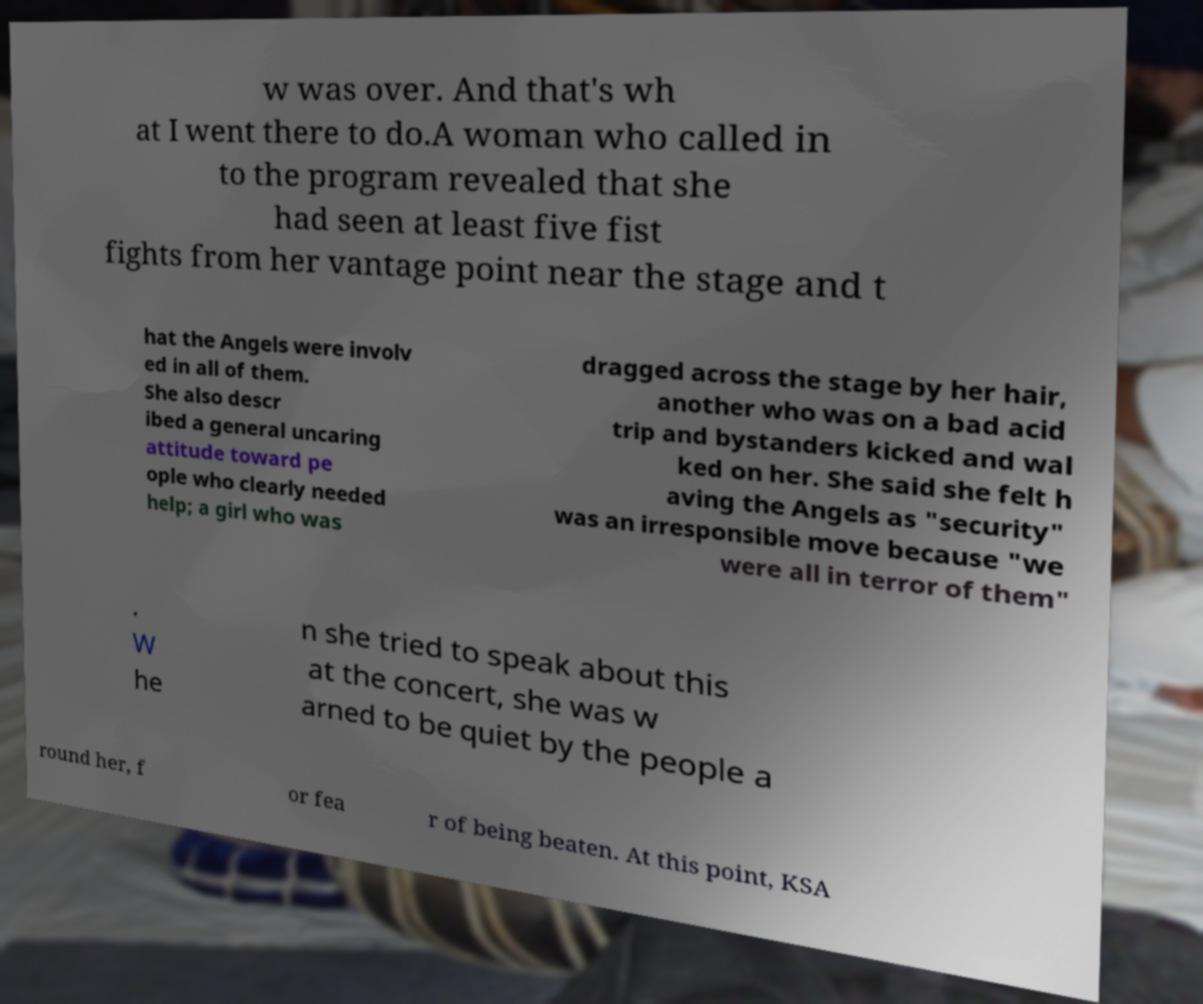Could you assist in decoding the text presented in this image and type it out clearly? w was over. And that's wh at I went there to do.A woman who called in to the program revealed that she had seen at least five fist fights from her vantage point near the stage and t hat the Angels were involv ed in all of them. She also descr ibed a general uncaring attitude toward pe ople who clearly needed help; a girl who was dragged across the stage by her hair, another who was on a bad acid trip and bystanders kicked and wal ked on her. She said she felt h aving the Angels as "security" was an irresponsible move because "we were all in terror of them" . W he n she tried to speak about this at the concert, she was w arned to be quiet by the people a round her, f or fea r of being beaten. At this point, KSA 